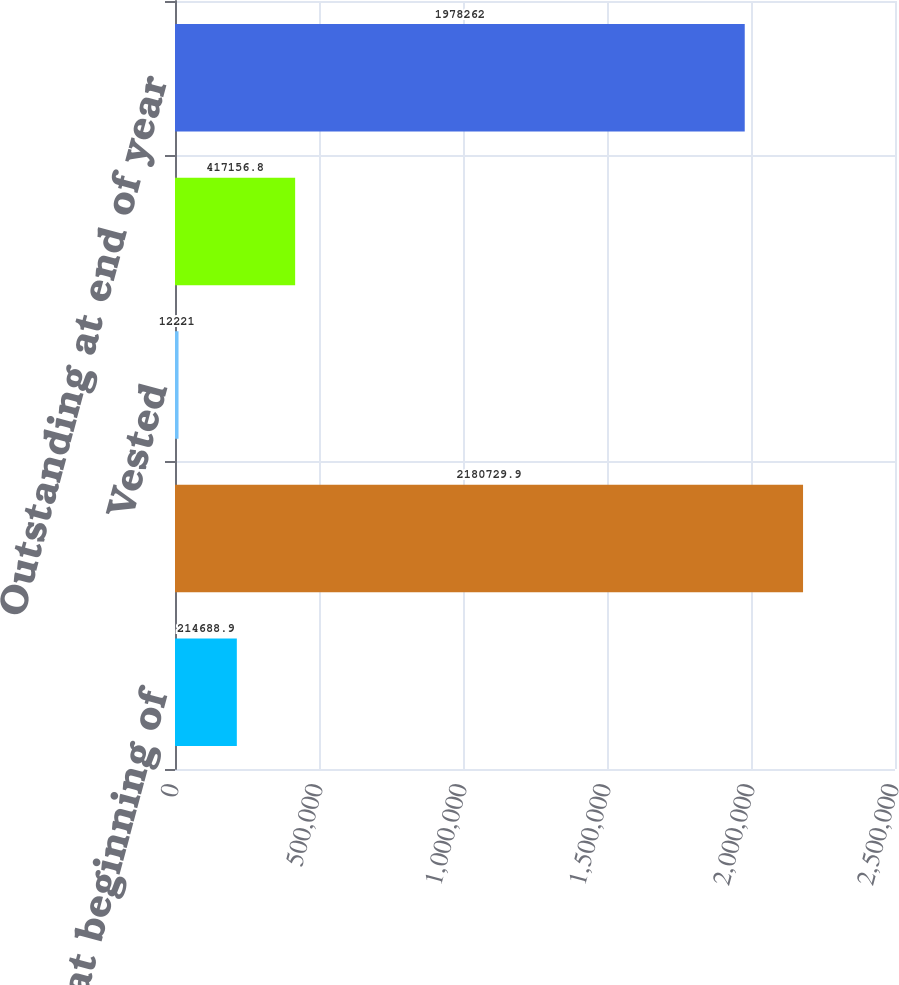Convert chart to OTSL. <chart><loc_0><loc_0><loc_500><loc_500><bar_chart><fcel>Outstanding at beginning of<fcel>Granted<fcel>Vested<fcel>Cancelled<fcel>Outstanding at end of year<nl><fcel>214689<fcel>2.18073e+06<fcel>12221<fcel>417157<fcel>1.97826e+06<nl></chart> 